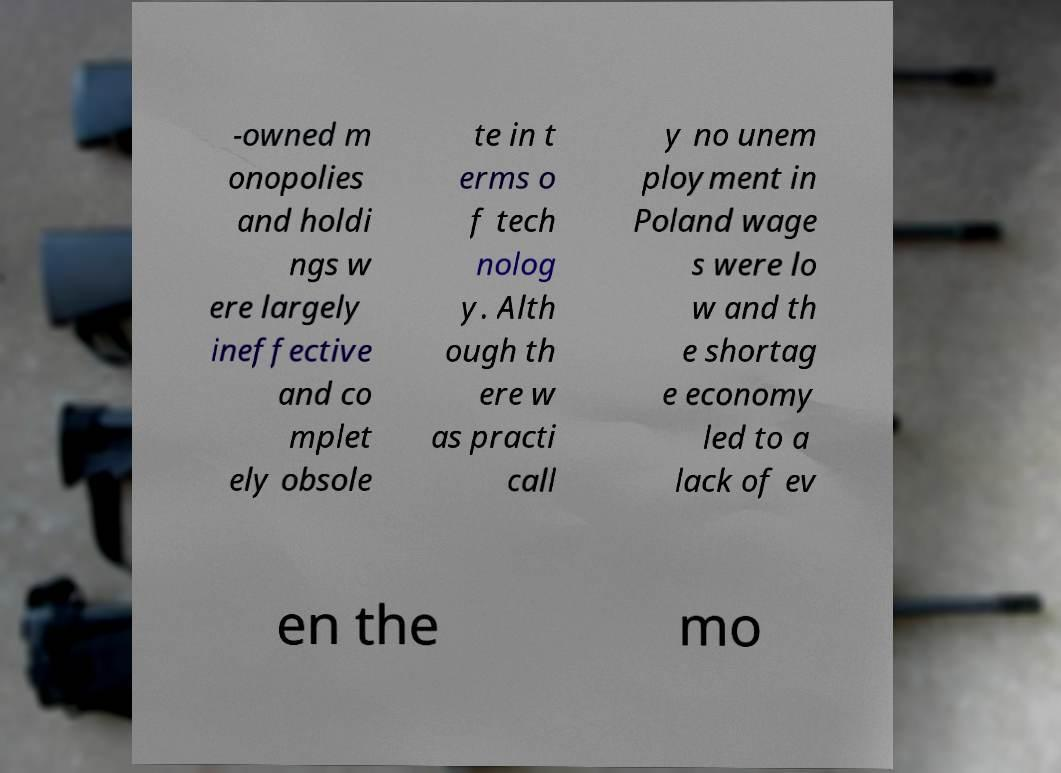Please identify and transcribe the text found in this image. -owned m onopolies and holdi ngs w ere largely ineffective and co mplet ely obsole te in t erms o f tech nolog y. Alth ough th ere w as practi call y no unem ployment in Poland wage s were lo w and th e shortag e economy led to a lack of ev en the mo 